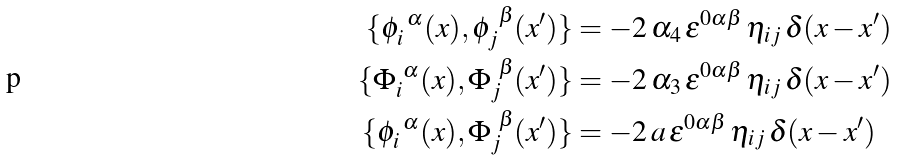Convert formula to latex. <formula><loc_0><loc_0><loc_500><loc_500>\{ \phi _ { i } ^ { \ \alpha } ( x ) , \phi _ { j } ^ { \ \beta } ( x ^ { \prime } ) \} & = - 2 \, \alpha _ { 4 } \, \varepsilon ^ { 0 \alpha \beta } \, \eta _ { i j } \, \delta ( x - x ^ { \prime } ) \\ \{ \Phi _ { i } ^ { \ \alpha } ( x ) , \Phi _ { j } ^ { \ \beta } ( x ^ { \prime } ) \} & = - 2 \, \alpha _ { 3 } \, \varepsilon ^ { 0 \alpha \beta } \, \eta _ { i j } \, \delta ( x - x ^ { \prime } ) \\ \{ \phi _ { i } ^ { \ \alpha } ( x ) , \Phi _ { j } ^ { \ \beta } ( x ^ { \prime } ) \} & = - 2 \, a \, \varepsilon ^ { 0 \alpha \beta } \, \eta _ { i j } \, \delta ( x - x ^ { \prime } ) \\</formula> 